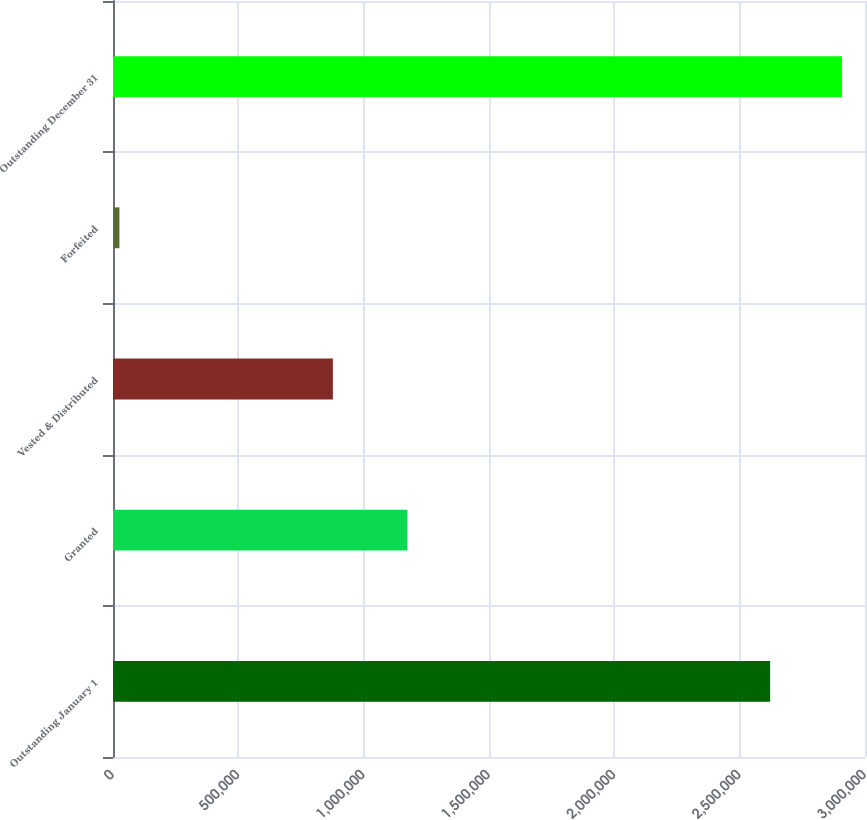Convert chart. <chart><loc_0><loc_0><loc_500><loc_500><bar_chart><fcel>Outstanding January 1<fcel>Granted<fcel>Vested & Distributed<fcel>Forfeited<fcel>Outstanding December 31<nl><fcel>2.62151e+06<fcel>1.1745e+06<fcel>877111<fcel>25623<fcel>2.90828e+06<nl></chart> 